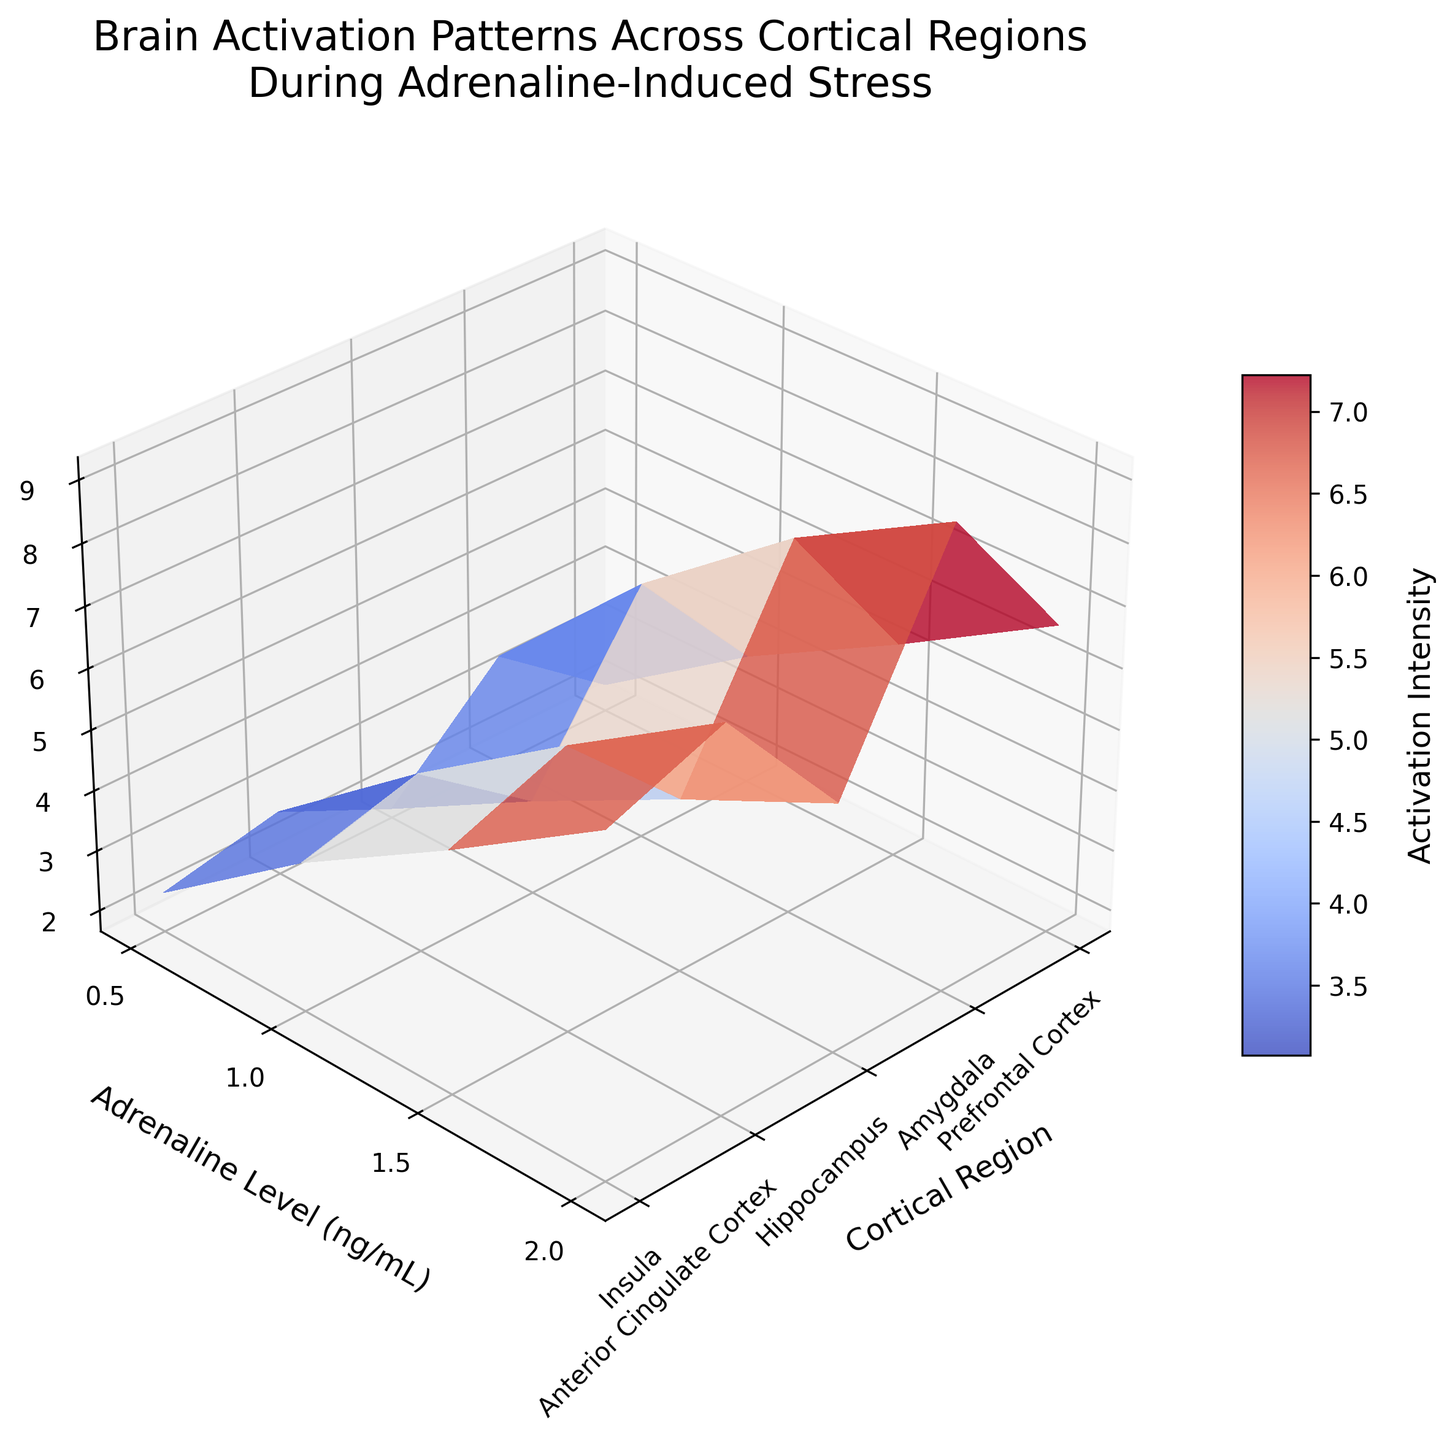What is the title of the figure? The title is found at the top of the figure. It provides a brief description of what the plot represents.
Answer: Brain Activation Patterns Across Cortical Regions During Adrenaline-Induced Stress Which cortical region has the highest activation intensity at an adrenaline level of 2.0 ng/mL? By looking at the data points at the adrenaline level of 2.0 ng/mL and comparing the activation intensities across the cortical regions, the Amygdala shows the highest value.
Answer: Amygdala How many unique adrenaline levels are plotted on the y-axis? The y-axis represents the adrenaline levels. Counting the unique values on this axis will give us the answer.
Answer: 4 Compare the activation intensity between the Prefrontal Cortex and the Insula at an adrenaline level of 1.5 ng/mL. Which one is higher, and by how much? Check the activation intensities for both regions at the specified adrenaline level. The Prefrontal Cortex has an activation intensity of 5.2, while the Insula has 5.6. The Insula's activation is higher by 0.4.
Answer: Insula, by 0.4 What pattern do you observe in the Activation Intensity as the Adrenaline Level increases from 0.5 to 2.0 ng/mL for the Anterior Cingulate Cortex? Observing the trend for the Anterior Cingulate Cortex as the adrenaline level increases, the activation intensity rises consistently from 2.7 at 0.5 ng/mL to 7.9 at 2.0 ng/mL, indicating an increasing pattern.
Answer: Increasing What is the average activation intensity for the hippocampus across all adrenaline levels? Sum the activation intensities for the hippocampus at all adrenaline levels and divide by the number of levels (4). (1.8 + 3.2 + 4.5 + 5.7) = 15.2; 15.2 / 4 = 3.8.
Answer: 3.8 Which cortisol level between 1.0 ng/mL and 1.5 ng/mL shows a greater difference in activation intensity between the Prefrontal Cortex and Amygdala? Find the activation intensities for both regions at 1.0 ng/mL (Prefrontal: 3.8, Amygdala: 5.9) and 1.5 ng/mL (Prefrontal: 5.2, Amygdala: 7.8). Calculate the differences: at 1.0 ng/mL = 2.1, at 1.5 ng/mL = 2.6.
Answer: 1.5 ng/mL How does the activation intensity for the Insula at an adrenaline level of 2.0 ng/mL compare to that of the Anterior Cingulate Cortex at the same adrenaline level? At an adrenaline level of 2.0 ng/mL, the activation intensity for the Insula is 7.2, while for the Anterior Cingulate Cortex, it is 7.9.
Answer: Anterior Cingulate Cortex is higher than Insula What does the color gradient in the plot represent? The color gradient helps visualize varying levels of activation intensity. Warmer colors (like reds) depict higher activation, while cooler colors (like blues) depict lower activation.
Answer: Activation Intensity 